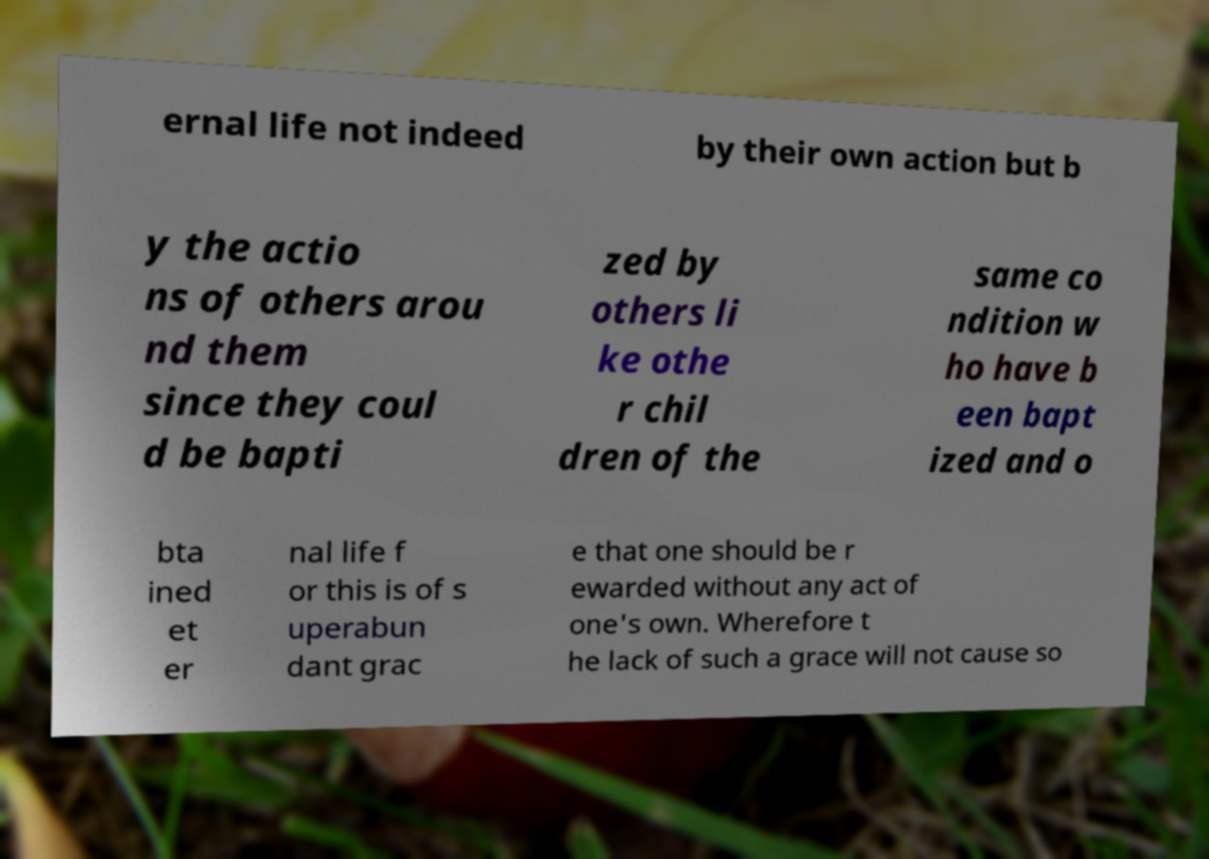Can you read and provide the text displayed in the image?This photo seems to have some interesting text. Can you extract and type it out for me? ernal life not indeed by their own action but b y the actio ns of others arou nd them since they coul d be bapti zed by others li ke othe r chil dren of the same co ndition w ho have b een bapt ized and o bta ined et er nal life f or this is of s uperabun dant grac e that one should be r ewarded without any act of one's own. Wherefore t he lack of such a grace will not cause so 